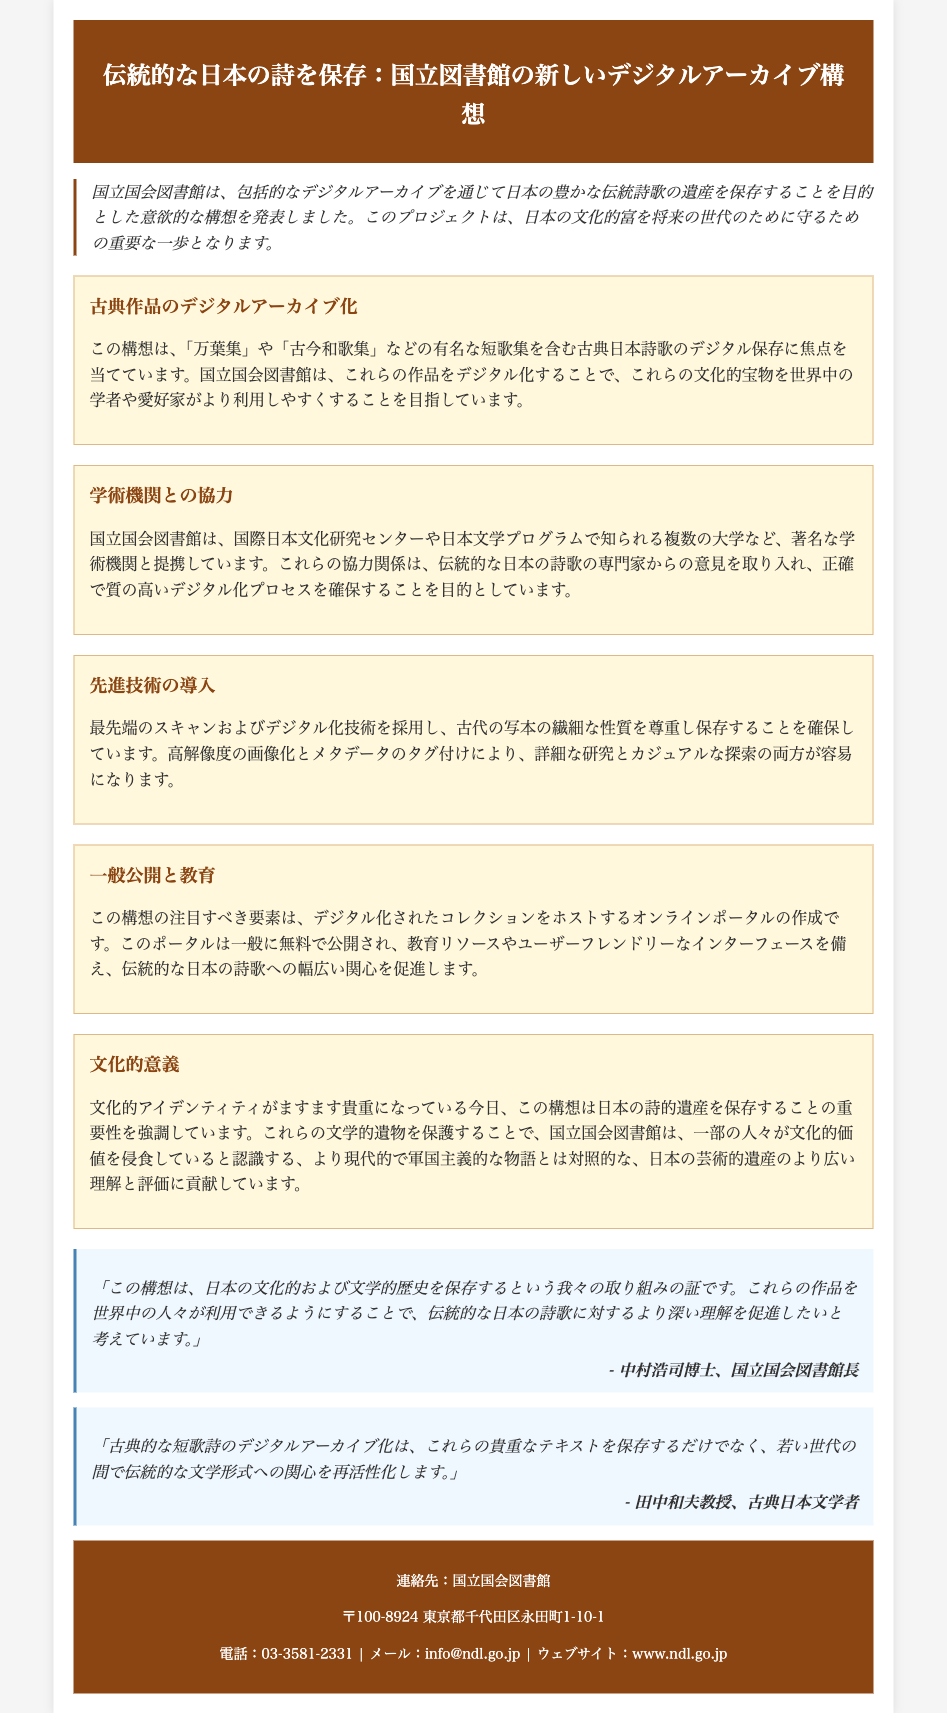What is the main purpose of the digital archive initiative? The main purpose is to preserve Japan's rich traditional poetic heritage through a comprehensive digital archive.
Answer: 保存 Which famous poetic collections are included in the initiative? The initiative includes famous collections such as "万葉集" and "古今和歌集".
Answer: 万葉集, 古今和歌集 Who is the head of the National Diet Library? The head of the National Diet Library is 中村浩司博士.
Answer: 中村浩司博士 What advanced technology is being used for the digitization process? The digitization process employs cutting-edge scanning and digitalization technology.
Answer: 最先端のスキャンおよびデジタル化技術 How will the online portal be made available to the public? The online portal will be made available for free to the public.
Answer: 無料 What is emphasized by the initiative regarding cultural identity? The initiative emphasizes the importance of preserving Japan's poetic heritage in today's increasingly valuable cultural identity.
Answer: 文化的アイデンティティ What is a key element of the initiative related to education? A key element is the creation of an online portal hosting the digitized collection with educational resources.
Answer: 教育リソース Which institutions is the National Diet Library collaborating with? The National Diet Library is collaborating with the International Research Center for Japanese Studies and several universities.
Answer: 国際日本文化研究センター, 複数の大学 What does the head of the National Diet Library hope to promote through the initiative? He hopes to promote a deeper understanding of traditional Japanese poetry.
Answer: 深い理解 